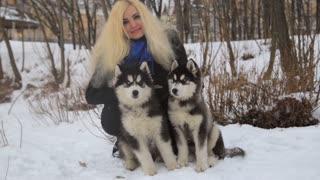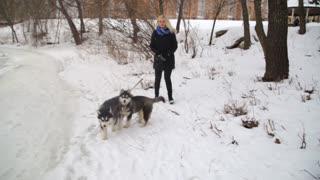The first image is the image on the left, the second image is the image on the right. Analyze the images presented: Is the assertion "The left image contains exactly two dogs." valid? Answer yes or no. Yes. The first image is the image on the left, the second image is the image on the right. Considering the images on both sides, is "Each image contains two husky dogs positioned close together, and one image features dogs standing on snow-covered ground." valid? Answer yes or no. Yes. 